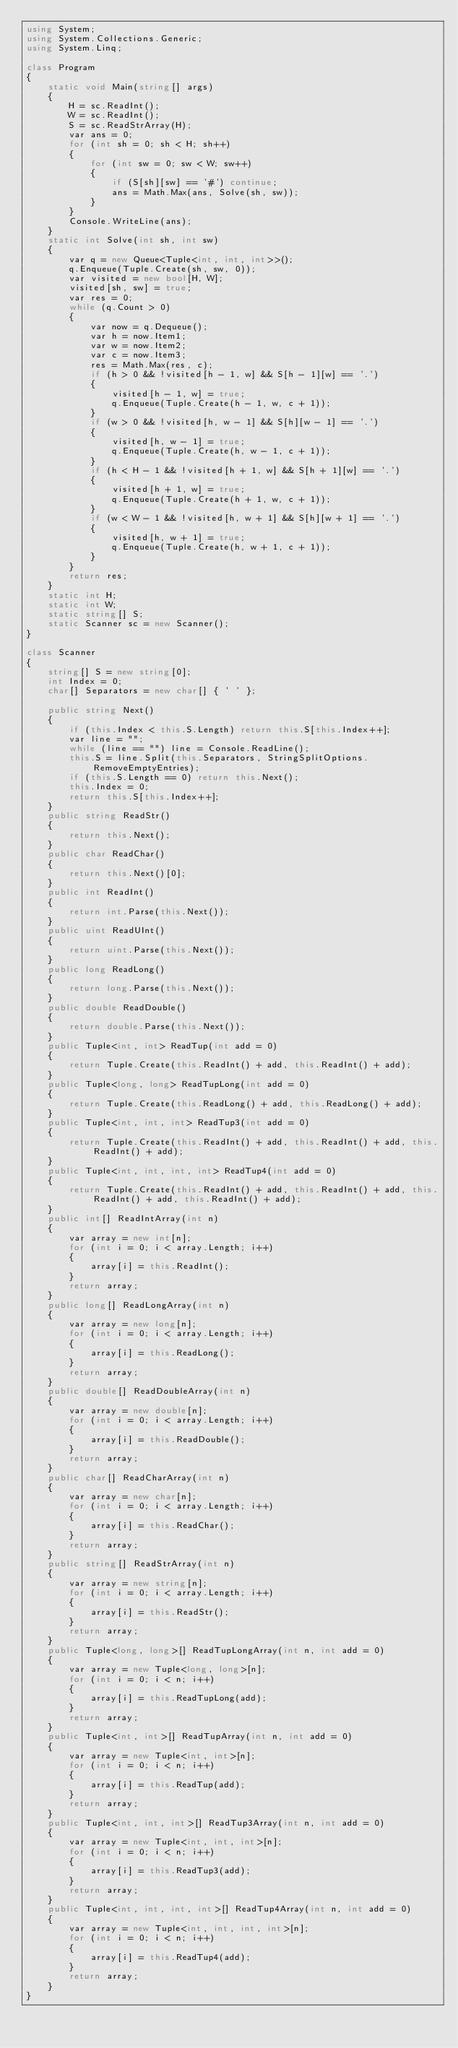Convert code to text. <code><loc_0><loc_0><loc_500><loc_500><_C#_>using System;
using System.Collections.Generic;
using System.Linq;

class Program
{
    static void Main(string[] args)
    {
        H = sc.ReadInt();
        W = sc.ReadInt();
        S = sc.ReadStrArray(H);
        var ans = 0;
        for (int sh = 0; sh < H; sh++)
        {
            for (int sw = 0; sw < W; sw++)
            {
                if (S[sh][sw] == '#') continue;
                ans = Math.Max(ans, Solve(sh, sw));
            }
        }
        Console.WriteLine(ans);
    }
    static int Solve(int sh, int sw)
    {
        var q = new Queue<Tuple<int, int, int>>();
        q.Enqueue(Tuple.Create(sh, sw, 0));
        var visited = new bool[H, W];
        visited[sh, sw] = true;
        var res = 0;
        while (q.Count > 0)
        {
            var now = q.Dequeue();
            var h = now.Item1;
            var w = now.Item2;
            var c = now.Item3;
            res = Math.Max(res, c);
            if (h > 0 && !visited[h - 1, w] && S[h - 1][w] == '.')
            {
                visited[h - 1, w] = true;
                q.Enqueue(Tuple.Create(h - 1, w, c + 1));
            }
            if (w > 0 && !visited[h, w - 1] && S[h][w - 1] == '.')
            {
                visited[h, w - 1] = true;
                q.Enqueue(Tuple.Create(h, w - 1, c + 1));
            }
            if (h < H - 1 && !visited[h + 1, w] && S[h + 1][w] == '.')
            {
                visited[h + 1, w] = true;
                q.Enqueue(Tuple.Create(h + 1, w, c + 1));
            }
            if (w < W - 1 && !visited[h, w + 1] && S[h][w + 1] == '.')
            {
                visited[h, w + 1] = true;
                q.Enqueue(Tuple.Create(h, w + 1, c + 1));
            }
        }
        return res;
    }
    static int H;
    static int W;
    static string[] S;
    static Scanner sc = new Scanner();
}

class Scanner
{
    string[] S = new string[0];
    int Index = 0;
    char[] Separators = new char[] { ' ' };

    public string Next()
    {
        if (this.Index < this.S.Length) return this.S[this.Index++];
        var line = "";
        while (line == "") line = Console.ReadLine();
        this.S = line.Split(this.Separators, StringSplitOptions.RemoveEmptyEntries);
        if (this.S.Length == 0) return this.Next();
        this.Index = 0;
        return this.S[this.Index++];
    }
    public string ReadStr()
    {
        return this.Next();
    }
    public char ReadChar()
    {
        return this.Next()[0];
    }
    public int ReadInt()
    {
        return int.Parse(this.Next());
    }
    public uint ReadUInt()
    {
        return uint.Parse(this.Next());
    }
    public long ReadLong()
    {
        return long.Parse(this.Next());
    }
    public double ReadDouble()
    {
        return double.Parse(this.Next());
    }
    public Tuple<int, int> ReadTup(int add = 0)
    {
        return Tuple.Create(this.ReadInt() + add, this.ReadInt() + add);
    }
    public Tuple<long, long> ReadTupLong(int add = 0)
    {
        return Tuple.Create(this.ReadLong() + add, this.ReadLong() + add);
    }
    public Tuple<int, int, int> ReadTup3(int add = 0)
    {
        return Tuple.Create(this.ReadInt() + add, this.ReadInt() + add, this.ReadInt() + add);
    }
    public Tuple<int, int, int, int> ReadTup4(int add = 0)
    {
        return Tuple.Create(this.ReadInt() + add, this.ReadInt() + add, this.ReadInt() + add, this.ReadInt() + add);
    }
    public int[] ReadIntArray(int n)
    {
        var array = new int[n];
        for (int i = 0; i < array.Length; i++)
        {
            array[i] = this.ReadInt();
        }
        return array;
    }
    public long[] ReadLongArray(int n)
    {
        var array = new long[n];
        for (int i = 0; i < array.Length; i++)
        {
            array[i] = this.ReadLong();
        }
        return array;
    }
    public double[] ReadDoubleArray(int n)
    {
        var array = new double[n];
        for (int i = 0; i < array.Length; i++)
        {
            array[i] = this.ReadDouble();
        }
        return array;
    }
    public char[] ReadCharArray(int n)
    {
        var array = new char[n];
        for (int i = 0; i < array.Length; i++)
        {
            array[i] = this.ReadChar();
        }
        return array;
    }
    public string[] ReadStrArray(int n)
    {
        var array = new string[n];
        for (int i = 0; i < array.Length; i++)
        {
            array[i] = this.ReadStr();
        }
        return array;
    }
    public Tuple<long, long>[] ReadTupLongArray(int n, int add = 0)
    {
        var array = new Tuple<long, long>[n];
        for (int i = 0; i < n; i++)
        {
            array[i] = this.ReadTupLong(add);
        }
        return array;
    }
    public Tuple<int, int>[] ReadTupArray(int n, int add = 0)
    {
        var array = new Tuple<int, int>[n];
        for (int i = 0; i < n; i++)
        {
            array[i] = this.ReadTup(add);
        }
        return array;
    }
    public Tuple<int, int, int>[] ReadTup3Array(int n, int add = 0)
    {
        var array = new Tuple<int, int, int>[n];
        for (int i = 0; i < n; i++)
        {
            array[i] = this.ReadTup3(add);
        }
        return array;
    }
    public Tuple<int, int, int, int>[] ReadTup4Array(int n, int add = 0)
    {
        var array = new Tuple<int, int, int, int>[n];
        for (int i = 0; i < n; i++)
        {
            array[i] = this.ReadTup4(add);
        }
        return array;
    }
}
</code> 